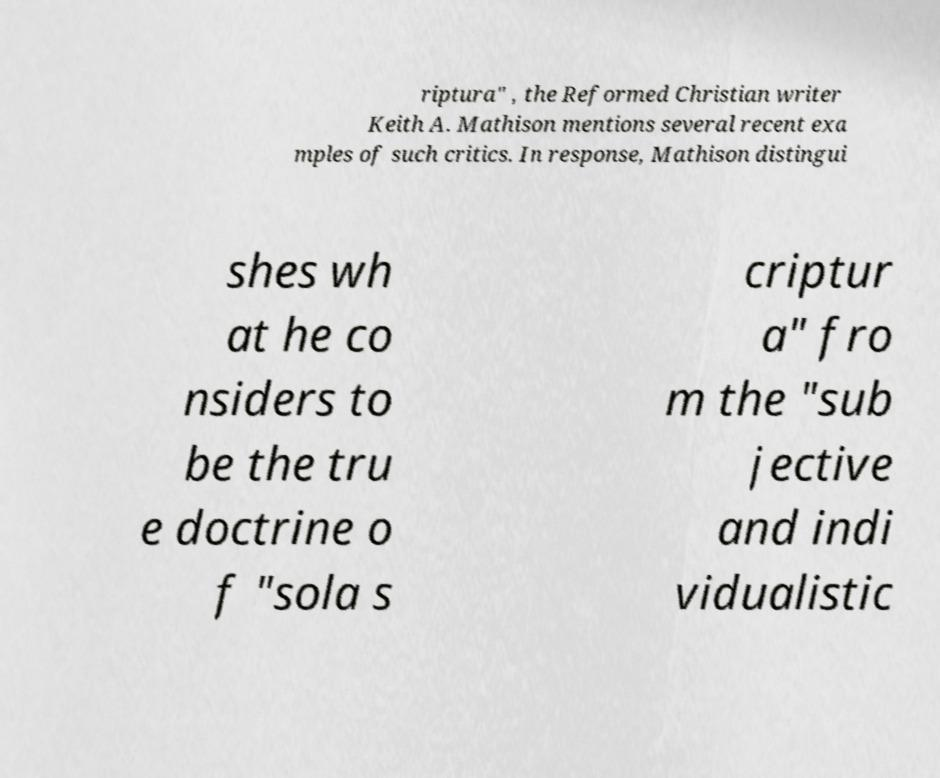Can you read and provide the text displayed in the image?This photo seems to have some interesting text. Can you extract and type it out for me? riptura" , the Reformed Christian writer Keith A. Mathison mentions several recent exa mples of such critics. In response, Mathison distingui shes wh at he co nsiders to be the tru e doctrine o f "sola s criptur a" fro m the "sub jective and indi vidualistic 